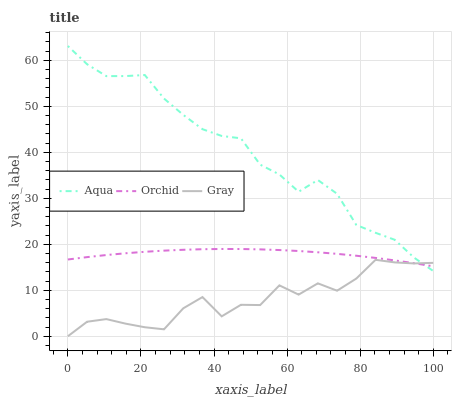Does Gray have the minimum area under the curve?
Answer yes or no. Yes. Does Aqua have the maximum area under the curve?
Answer yes or no. Yes. Does Orchid have the minimum area under the curve?
Answer yes or no. No. Does Orchid have the maximum area under the curve?
Answer yes or no. No. Is Orchid the smoothest?
Answer yes or no. Yes. Is Gray the roughest?
Answer yes or no. Yes. Is Aqua the smoothest?
Answer yes or no. No. Is Aqua the roughest?
Answer yes or no. No. Does Gray have the lowest value?
Answer yes or no. Yes. Does Aqua have the lowest value?
Answer yes or no. No. Does Aqua have the highest value?
Answer yes or no. Yes. Does Orchid have the highest value?
Answer yes or no. No. Does Orchid intersect Aqua?
Answer yes or no. Yes. Is Orchid less than Aqua?
Answer yes or no. No. Is Orchid greater than Aqua?
Answer yes or no. No. 